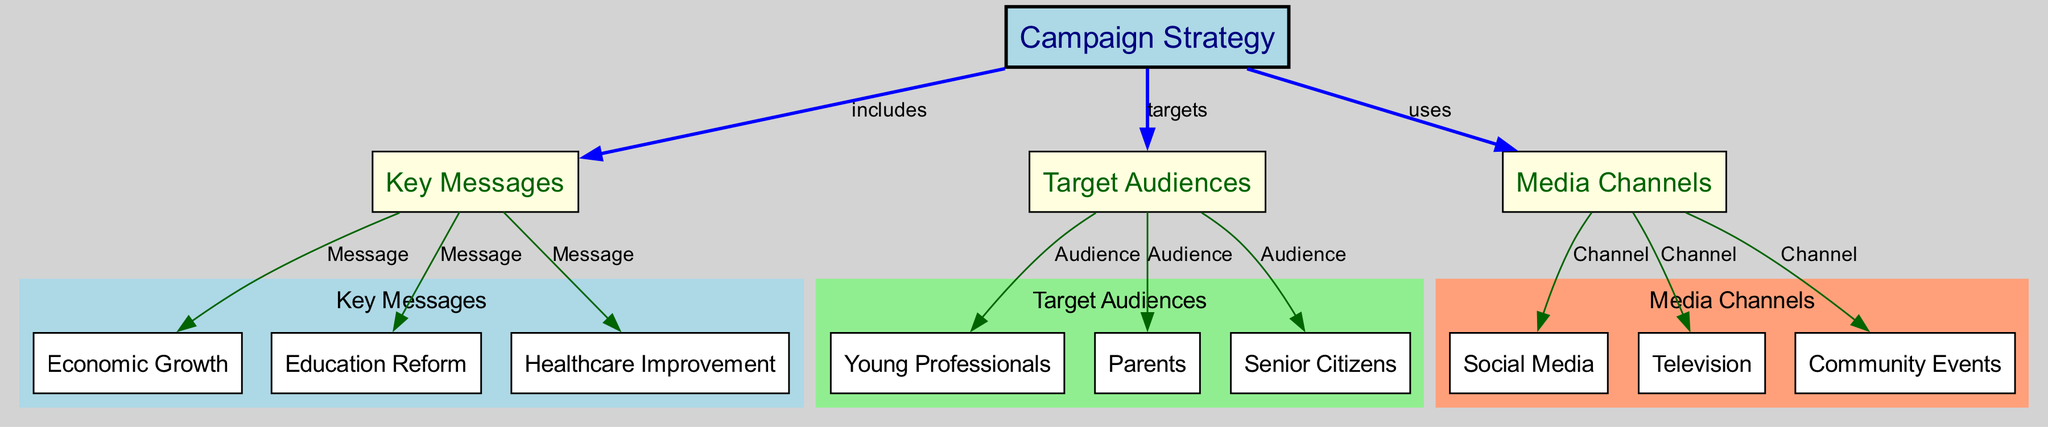What is the central node of the diagram? The central node is "Campaign Strategy," which denotes the overall framework around which key messages, target audiences, and media channels are organized.
Answer: Campaign Strategy How many key messages are represented in the diagram? There are three key messages identified: Economic Growth, Education Reform, and Healthcare Improvement. Count the nodes directly connected to "Key Messages."
Answer: 3 Which target audience is connected to "Education Reform"? The node "Education Reform" is directly connected to "Key Messages," not specifically to the target audience. However, we know that "Parents" is a likely target audience because educational reform often focuses on parental concerns.
Answer: Parents What type of media channel is connected to "Television"? "Television" is one of the media channels identified in the diagram, which falls under the category of "Media Channels." It directly connects to the "Campaign Strategy" node.
Answer: Media Channel Which key message is targeting "Young Professionals"? The diagram indicates that "Young Professionals" is connected to the "Target Audiences" node, but it does not specify a direct key message related to them. Therefore, it is implied that there might be a broader connection to key messages like Economic Growth that would attract this audience.
Answer: Economic Growth What is the relationship between "Target Audiences" and "Media Channels"? The relationship is established through the "Campaign Strategy" node, which identifies that both of these categories are integral components of the overall strategy. "Target Audiences" leads to "Media Channels" via shared goals and methods of outreach.
Answer: Uses List the media channels mentioned in the diagram. The media channels illustrated include Social Media, Television, and Community Events, all of which are connected under the "Media Channels" category.
Answer: Social Media, Television, Community Events Which audience is most likely to be targeted by messages of "Healthcare Improvement"? The "Senior Citizens" audience is specifically connected to the key message of "Healthcare Improvement," indicating that this message is designed for them, aligning with healthcare reforms.
Answer: Senior Citizens How many edges are there connecting "Campaign Strategy" to other nodes? There are three edges emanating from "Campaign Strategy," connecting it to Key Messages, Target Audiences, and Media Channels. Each edge indicates a distinct relationship to those categories.
Answer: 3 